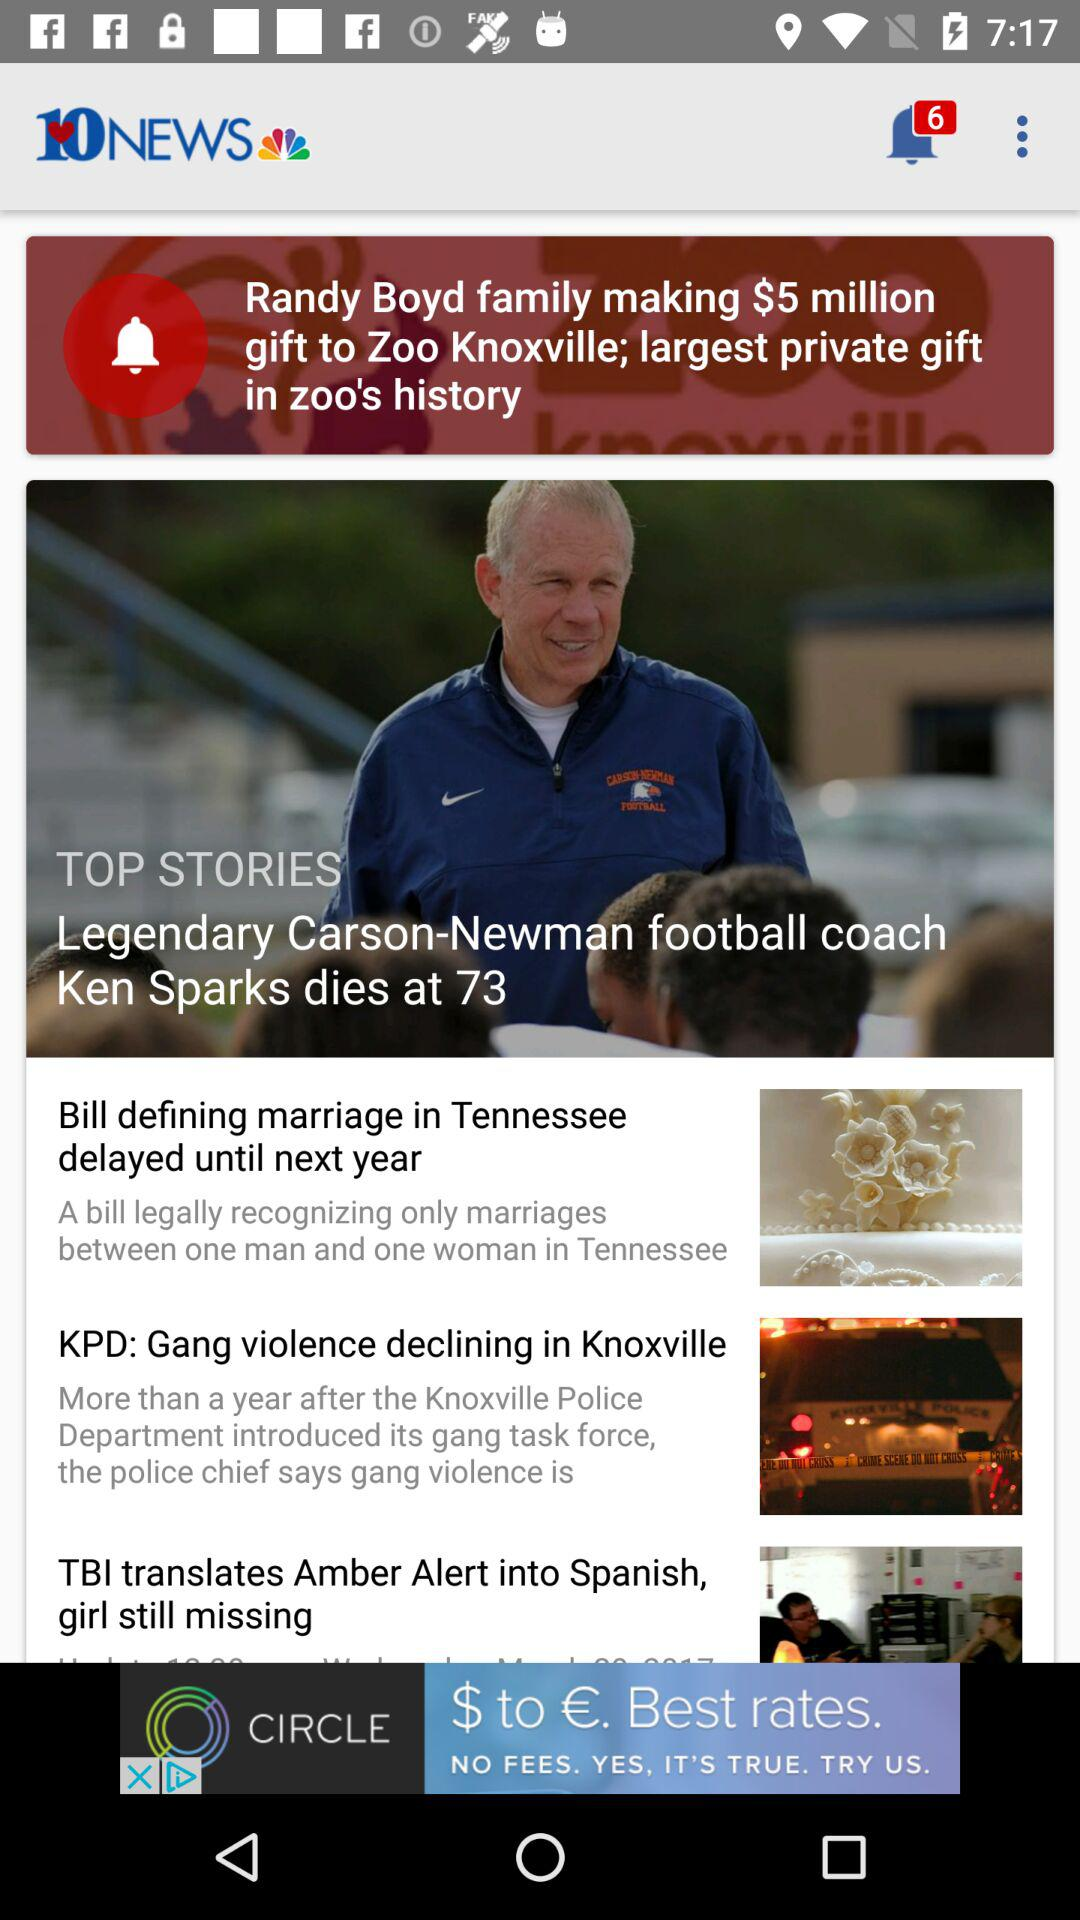How many more stories are there after the top stories?
Answer the question using a single word or phrase. 3 